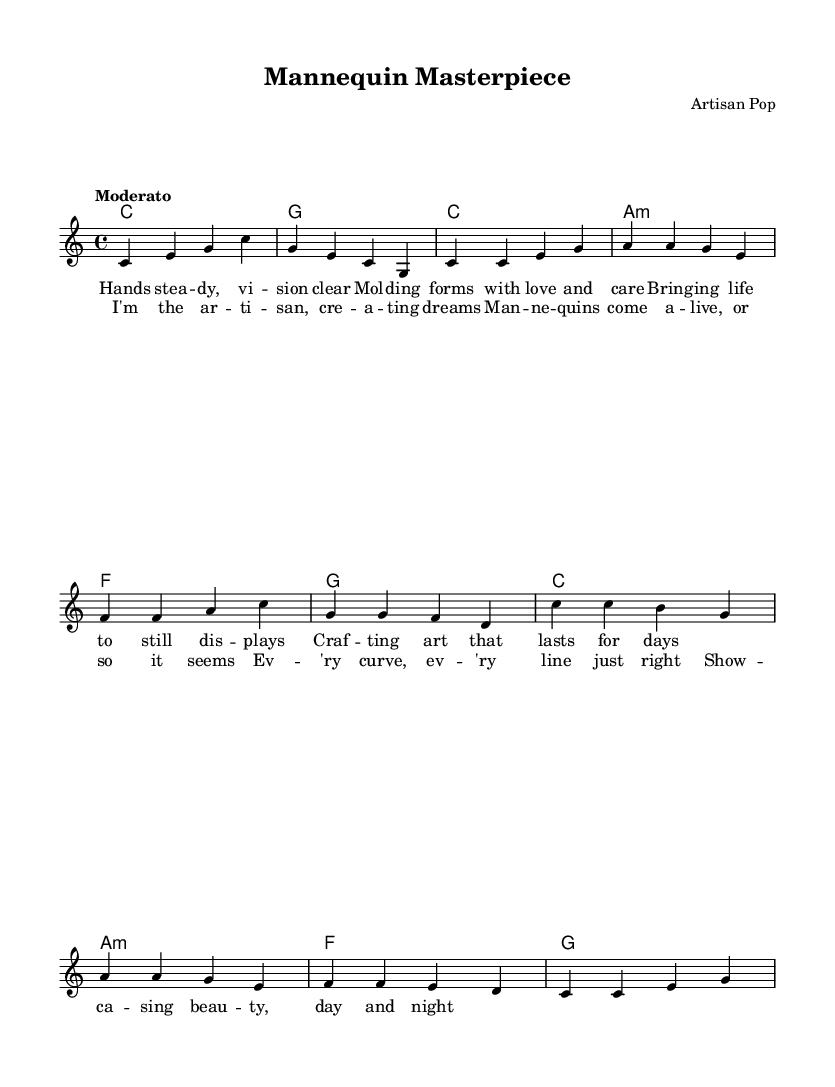What is the key signature of this music? The key signature is indicated at the beginning of the staff, and it shows no sharps or flats, which corresponds to C major.
Answer: C major What is the time signature? The time signature appears at the beginning of the music and is displayed as 4/4, indicating four beats per measure.
Answer: 4/4 What is the tempo marking? The tempo is indicated in the score as "Moderato," which is a common tempo marking that suggests a moderate pace.
Answer: Moderato How many measures are in the verse? The verse is comprised of four lines with four measures each, totaling 16 measures.
Answer: 16 What is the mood reflected in the lyrics? The lyrics express themes of creation and craftsmanship, showcasing passion and care in the artistic process.
Answer: Passion and care How many distinct sections are in this piece? The piece includes two main sections: the verse and the chorus. Thus, there are two distinct sections alternating in structure.
Answer: 2 What is the primary subject of the lyrics? The lyrics focus on the theme of an artisan crafting mannequins and the beauty of displaying art, reflecting on the creative process.
Answer: Craftsmanship 